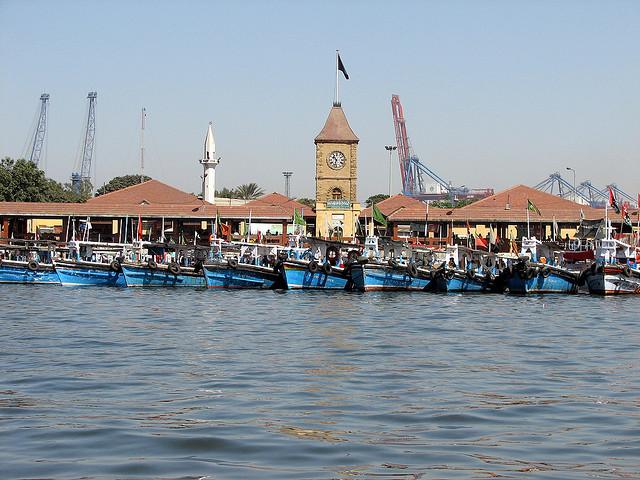Where are the boats parked?
Give a very brief answer. Dock. Is that a missile in the background?
Give a very brief answer. No. How many boats can you count?
Be succinct. 9. Overcast or sunny?
Short answer required. Sunny. 